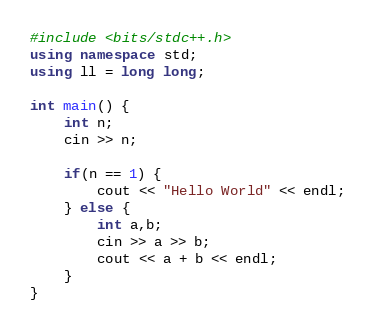Convert code to text. <code><loc_0><loc_0><loc_500><loc_500><_C++_>#include <bits/stdc++.h>
using namespace std;
using ll = long long;

int main() {
    int n;
    cin >> n;
    
    if(n == 1) {
        cout << "Hello World" << endl;
    } else {
        int a,b;
        cin >> a >> b;
        cout << a + b << endl;
    }
}</code> 